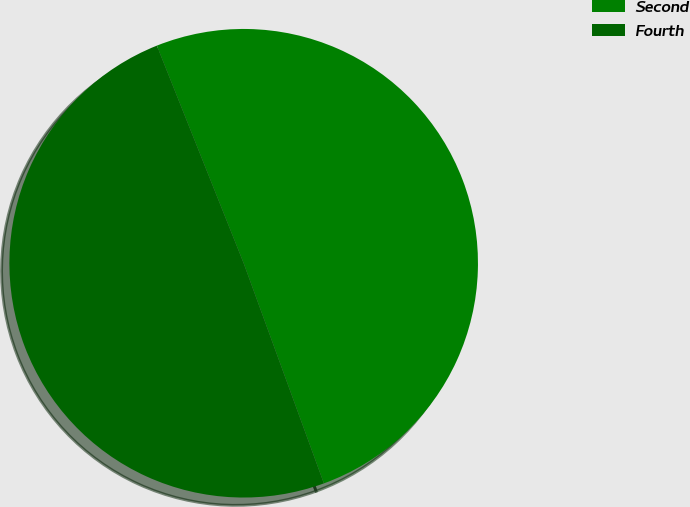Convert chart. <chart><loc_0><loc_0><loc_500><loc_500><pie_chart><fcel>Second<fcel>Fourth<nl><fcel>50.48%<fcel>49.52%<nl></chart> 